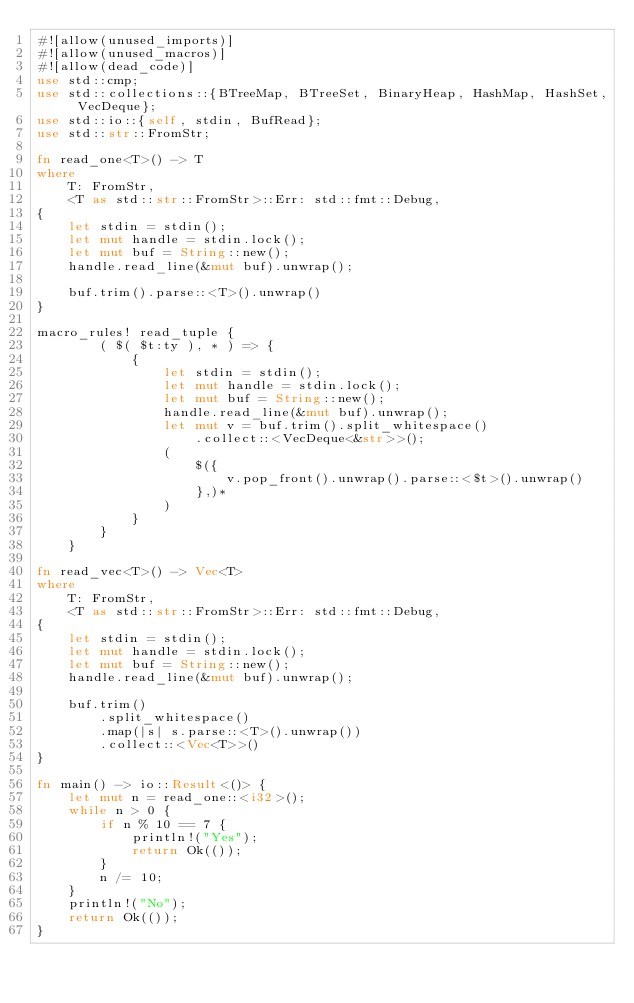<code> <loc_0><loc_0><loc_500><loc_500><_Rust_>#![allow(unused_imports)]
#![allow(unused_macros)]
#![allow(dead_code)]
use std::cmp;
use std::collections::{BTreeMap, BTreeSet, BinaryHeap, HashMap, HashSet, VecDeque};
use std::io::{self, stdin, BufRead};
use std::str::FromStr;

fn read_one<T>() -> T
where
    T: FromStr,
    <T as std::str::FromStr>::Err: std::fmt::Debug,
{
    let stdin = stdin();
    let mut handle = stdin.lock();
    let mut buf = String::new();
    handle.read_line(&mut buf).unwrap();

    buf.trim().parse::<T>().unwrap()
}

macro_rules! read_tuple {
        ( $( $t:ty ), * ) => {
            {
                let stdin = stdin();
                let mut handle = stdin.lock();
                let mut buf = String::new();
                handle.read_line(&mut buf).unwrap();
                let mut v = buf.trim().split_whitespace()
                    .collect::<VecDeque<&str>>();
                (
                    $({
                        v.pop_front().unwrap().parse::<$t>().unwrap()
                    },)*
                )
            }
        }
    }

fn read_vec<T>() -> Vec<T>
where
    T: FromStr,
    <T as std::str::FromStr>::Err: std::fmt::Debug,
{
    let stdin = stdin();
    let mut handle = stdin.lock();
    let mut buf = String::new();
    handle.read_line(&mut buf).unwrap();

    buf.trim()
        .split_whitespace()
        .map(|s| s.parse::<T>().unwrap())
        .collect::<Vec<T>>()
}

fn main() -> io::Result<()> {
    let mut n = read_one::<i32>();
    while n > 0 {
        if n % 10 == 7 {
            println!("Yes");
            return Ok(());
        }
        n /= 10;
    }
    println!("No");
    return Ok(());
}
</code> 